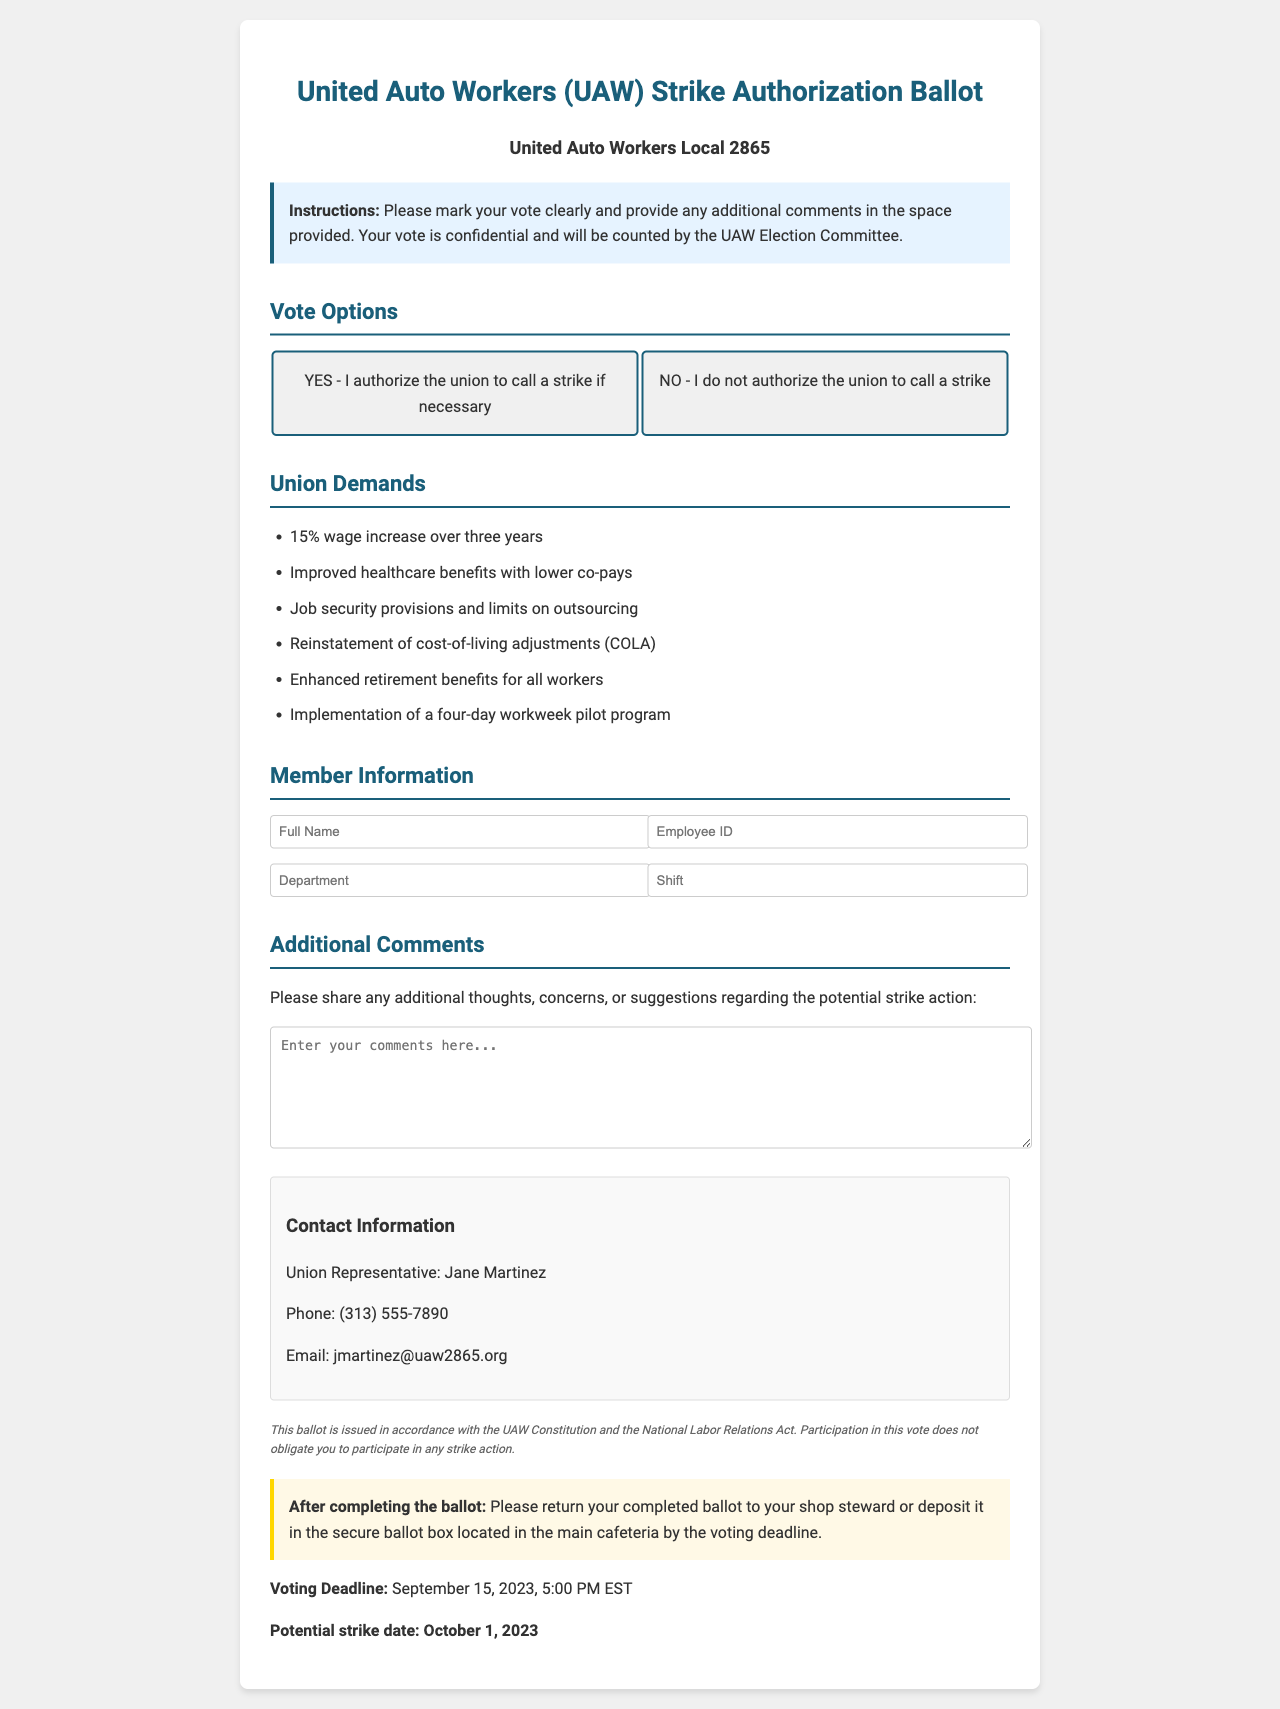what is the title of the document? The title is indicated at the top of the document.
Answer: United Auto Workers (UAW) Strike Authorization Ballot who is the union representative? The name of the union representative is provided in the contact information section.
Answer: Jane Martinez what is the voting deadline? The deadline for voting is clearly stated in the document.
Answer: September 15, 2023, 5:00 PM EST how many demands are listed by the union? The total number of demands can be counted from the provided list of union demands.
Answer: 6 what are the vote options provided? The vote options are specified in the vote options section of the document.
Answer: YES - I authorize the union to call a strike if necessary; NO - I do not authorize the union to call a strike what should members do with their completed ballot? This instruction can be found in the section that outlines what to do after completing the ballot.
Answer: Return to shop steward or deposit in the secure ballot box how is the ballot verified? The method used for verifying the ballot is mentioned in the document.
Answer: Unique QR code what is the potential strike date? The date for the potential strike is given in the document.
Answer: October 1, 2023 